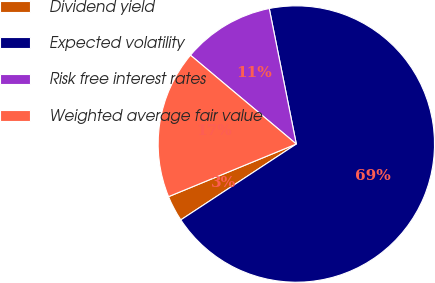Convert chart to OTSL. <chart><loc_0><loc_0><loc_500><loc_500><pie_chart><fcel>Dividend yield<fcel>Expected volatility<fcel>Risk free interest rates<fcel>Weighted average fair value<nl><fcel>3.03%<fcel>68.89%<fcel>10.75%<fcel>17.33%<nl></chart> 